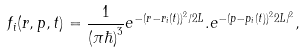Convert formula to latex. <formula><loc_0><loc_0><loc_500><loc_500>f _ { i } ( { r , p , t } ) = \frac { 1 } { ( \pi \hbar { ) } ^ { 3 } } e ^ { - ( { r } - { r } _ { i } ( t ) ) ^ { 2 } / 2 L } . e ^ { - ( { p } - { p } _ { i } ( t ) ) ^ { 2 } 2 L / { } ^ { 2 } } ,</formula> 